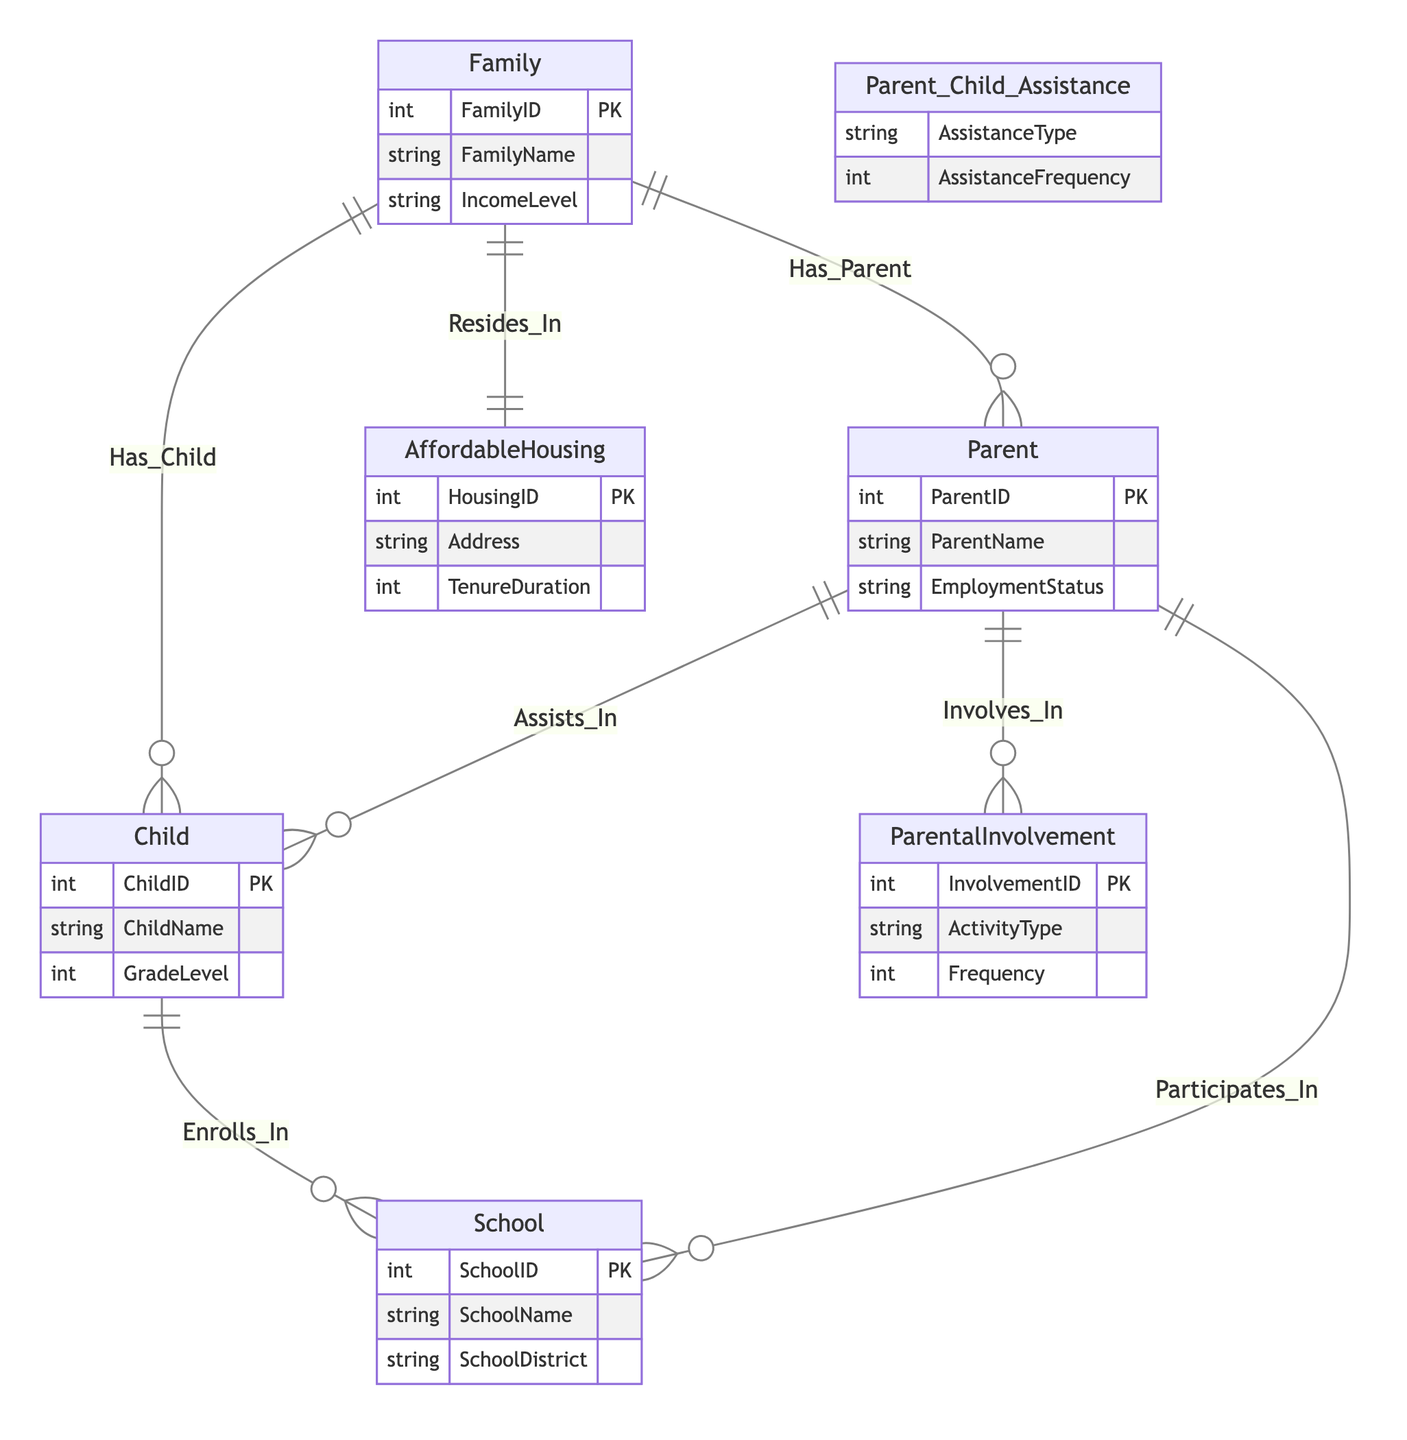What entities are involved in this diagram? The entities present in the diagram are Family, Parent, Child, School, AffordableHousing, and ParentalInvolvement. These entities represent different aspects of the relationships being analyzed in the context of parental involvement and housing.
Answer: Family, Parent, Child, School, AffordableHousing, ParentalInvolvement How many relationships are depicted in the diagram? The diagram shows a total of 7 relationships, illustrating how the various entities interact with one another, such as family residing in affordable housing and parents involving themselves in school activities.
Answer: 7 What relationship exists between Family and AffordableHousing? The relationship depicted is "Resides_In," indicating that a family lives in affordable housing, which connects the Family entity with the AffordableHousing entity in a direct manner.
Answer: Resides_In Which entity represents a child attending school? The Child entity represents an individual who enrolls in a school, connecting youth education to the overall diagram's theme of involvement and housing.
Answer: Child What type of involvement can a Parent have according to the diagram? According to the diagram, a parent can participate in activities represented in the ParentalInvolvement entity, such as assisting in their child's education or engaging in school events, which are crucial for overall educational outcomes.
Answer: ParentalInvolvement How are Parents and Children connected in the diagram? The connection is represented by the "Assists_In" relationship, indicating that parents provide assistance to their children in educational activities, highlighting the support mechanism in the family's educational environment.
Answer: Assists_In What is the primary function of the AffordableHousing entity? The AffordableHousing entity primarily functions to represent the housing arrangements and the duration of tenure for families, which can impact educational outcomes by influencing stability and community engagement.
Answer: Housing arrangements Which entity is responsible for defining the educational structure in a community? The School entity is responsible for defining the educational structure, including the various schools available for children to enroll and the school districts they belong to, thus shaping the educational landscape in the area.
Answer: School How is the relationship between Parent and School described? The relationship is described by "Participates_In," indicating that parents actively engage with schools, which could include attending meetings or helping out in school activities, thereby fostering stronger educational support for their children.
Answer: Participates_In 